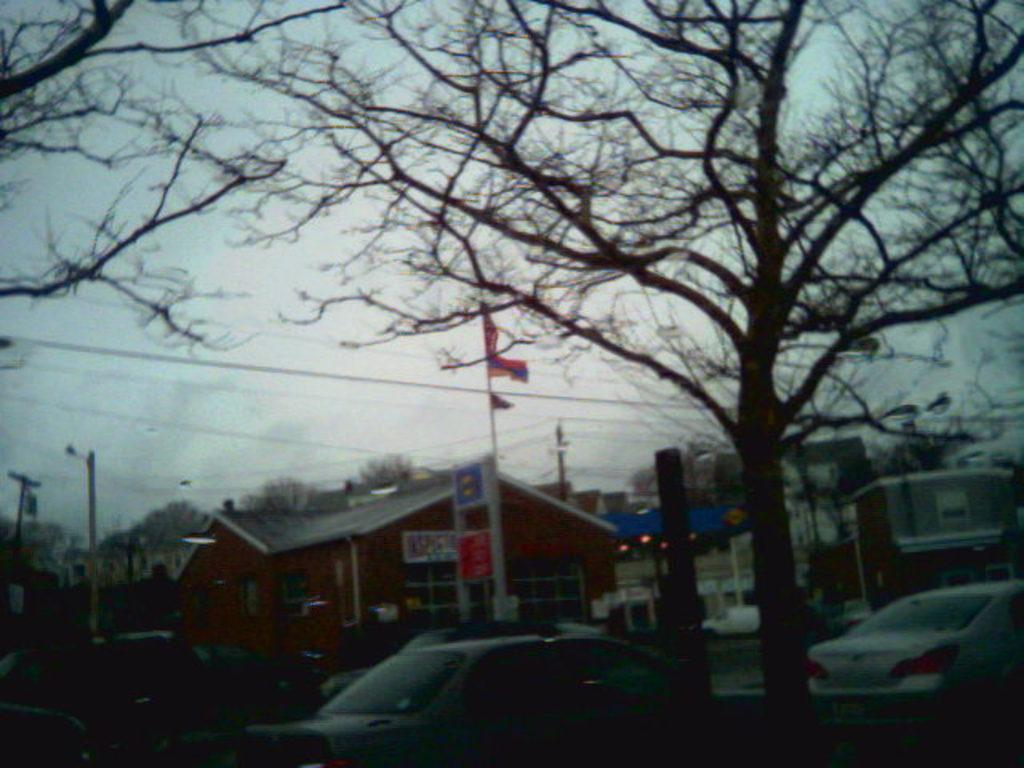What type of vegetation can be seen in the image? There are dried trees in the image. What mode of transportation can be seen on the road in the image? There are cars on the road in the image. What type of structure is present in the image? There is a house in the image. What else can be seen in the image besides the trees, cars, and house? There are wires visible in the image. What is visible in the background of the image? The sky is visible in the background of the image. Where is the prison located in the image? There is no prison present in the image. What type of blade is being used by the dad in the image? There is no dad or blade present in the image. 